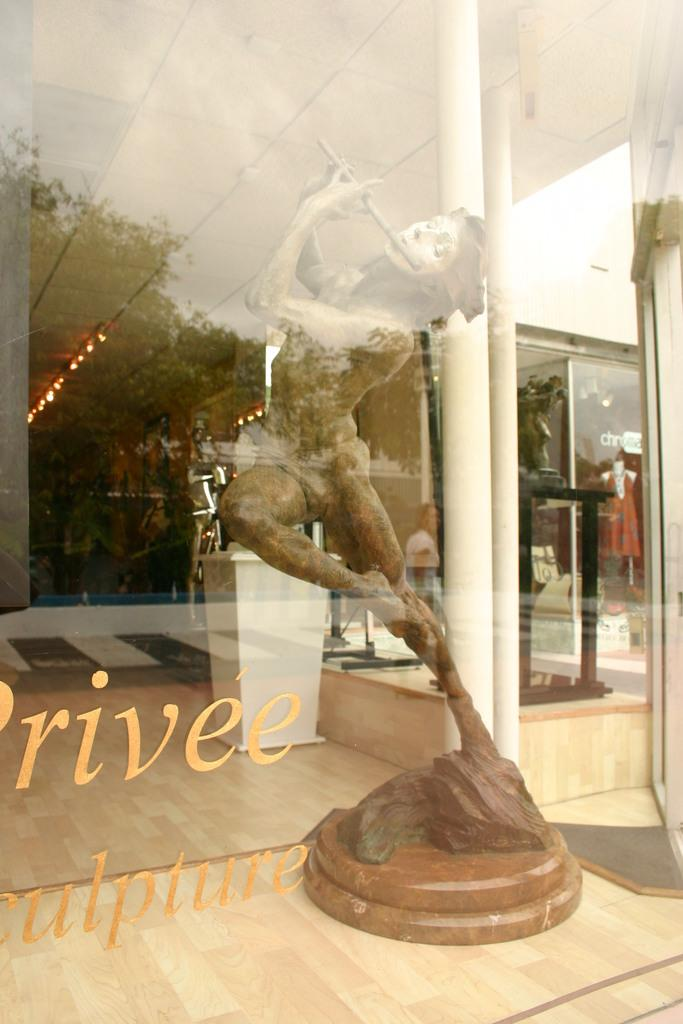What type of door is present in the image? There is a glass door in the image. What is written or displayed on the glass door? There is text on the glass door. What can be seen through the glass door? A sculpture, lights, a mannequin, and a stand are visible through the glass door. Are there any other objects visible through the glass door? Yes, other objects are visible through the glass door. How does the worm contribute to the increase in sales of the product displayed through the glass door? There is no worm present in the image, and the conversation does not mention any product or sales. 